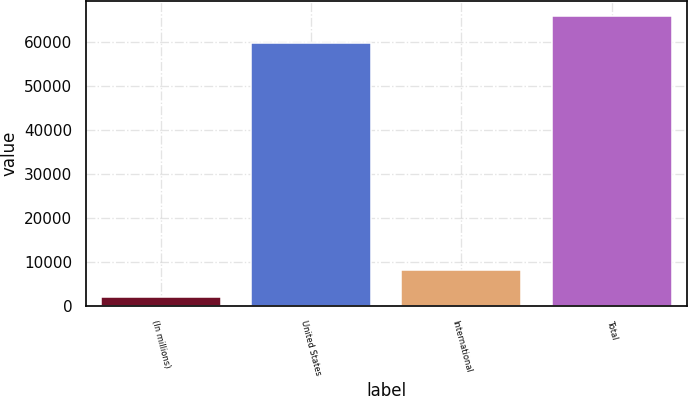Convert chart to OTSL. <chart><loc_0><loc_0><loc_500><loc_500><bar_chart><fcel>(In millions)<fcel>United States<fcel>International<fcel>Total<nl><fcel>2006<fcel>59723<fcel>8295<fcel>66012<nl></chart> 